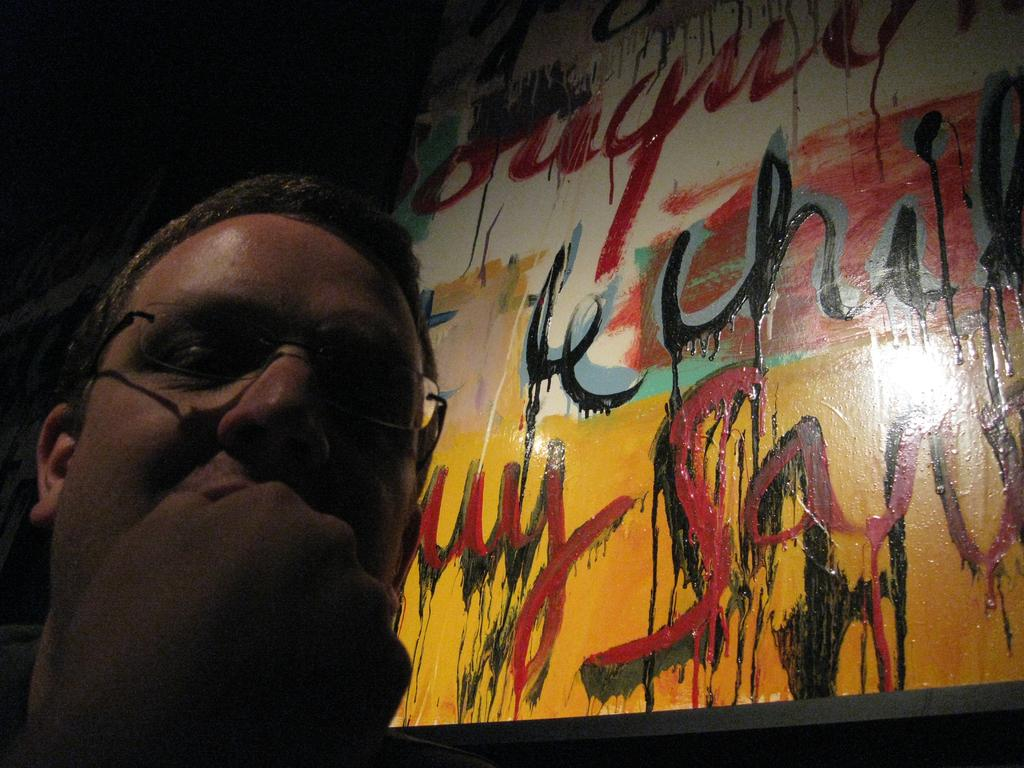What can be seen in the image? There is a person in the image. Can you describe the person's appearance? The person is wearing spectacles. What is present on the wall in the image? There is a painting on the wall in the image. What type of clam is being used as a bookmark in the image? There is no clam or book present in the image, so it is not possible to determine if a clam is being used as a bookmark. 